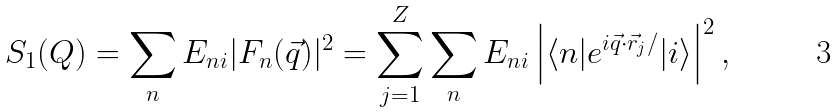<formula> <loc_0><loc_0><loc_500><loc_500>S _ { 1 } ( Q ) = \sum _ { n } E _ { n i } | F _ { n } ( \vec { q } ) | ^ { 2 } = \sum _ { j = 1 } ^ { Z } \sum _ { n } E _ { n i } \left | \langle n | e ^ { i \vec { q } \cdot \vec { r } _ { j } / } | i \rangle \right | ^ { 2 } ,</formula> 